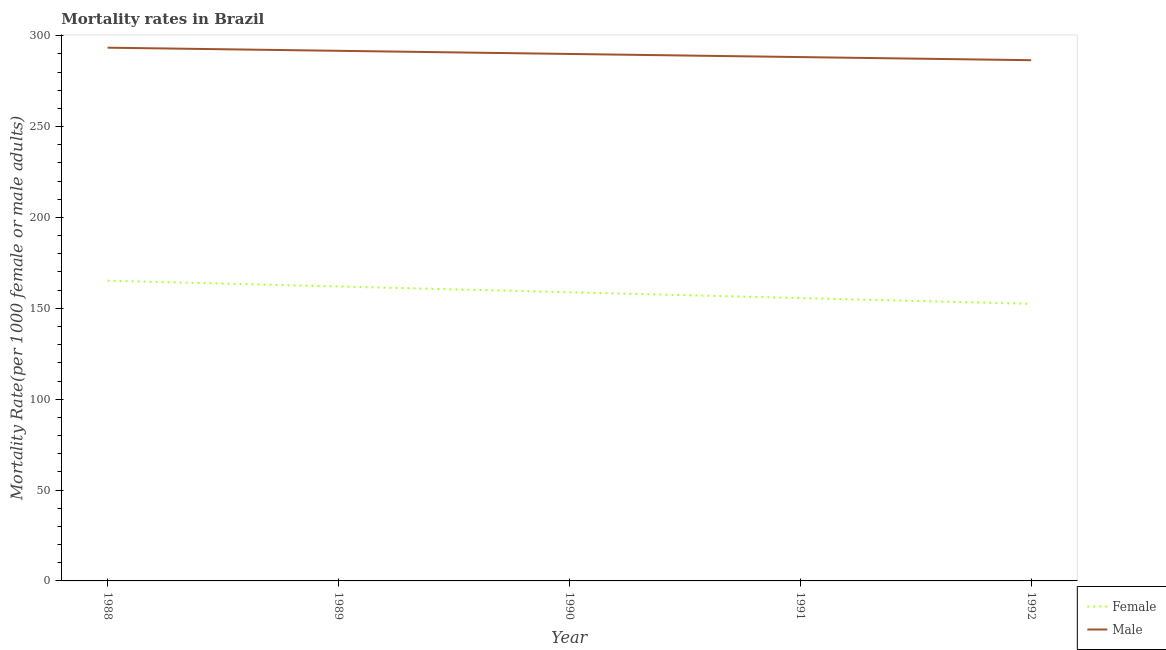Does the line corresponding to male mortality rate intersect with the line corresponding to female mortality rate?
Your answer should be compact. No. What is the female mortality rate in 1990?
Your answer should be very brief. 158.83. Across all years, what is the maximum female mortality rate?
Make the answer very short. 165.19. Across all years, what is the minimum male mortality rate?
Your answer should be compact. 286.51. In which year was the male mortality rate minimum?
Keep it short and to the point. 1992. What is the total male mortality rate in the graph?
Your answer should be compact. 1449.78. What is the difference between the female mortality rate in 1988 and that in 1989?
Offer a very short reply. 3.18. What is the difference between the female mortality rate in 1991 and the male mortality rate in 1988?
Offer a terse response. -137.76. What is the average male mortality rate per year?
Keep it short and to the point. 289.96. In the year 1991, what is the difference between the female mortality rate and male mortality rate?
Offer a terse response. -132.59. In how many years, is the female mortality rate greater than 130?
Keep it short and to the point. 5. What is the ratio of the male mortality rate in 1990 to that in 1992?
Keep it short and to the point. 1.01. What is the difference between the highest and the second highest female mortality rate?
Offer a terse response. 3.18. What is the difference between the highest and the lowest male mortality rate?
Provide a short and direct response. 6.89. Is the sum of the male mortality rate in 1988 and 1990 greater than the maximum female mortality rate across all years?
Your answer should be compact. Yes. Does the female mortality rate monotonically increase over the years?
Give a very brief answer. No. Is the male mortality rate strictly greater than the female mortality rate over the years?
Your response must be concise. Yes. How many lines are there?
Your answer should be very brief. 2. Are the values on the major ticks of Y-axis written in scientific E-notation?
Ensure brevity in your answer.  No. Where does the legend appear in the graph?
Keep it short and to the point. Bottom right. How are the legend labels stacked?
Ensure brevity in your answer.  Vertical. What is the title of the graph?
Provide a short and direct response. Mortality rates in Brazil. What is the label or title of the X-axis?
Your response must be concise. Year. What is the label or title of the Y-axis?
Your answer should be compact. Mortality Rate(per 1000 female or male adults). What is the Mortality Rate(per 1000 female or male adults) in Female in 1988?
Provide a succinct answer. 165.19. What is the Mortality Rate(per 1000 female or male adults) in Male in 1988?
Your answer should be compact. 293.4. What is the Mortality Rate(per 1000 female or male adults) in Female in 1989?
Your answer should be compact. 162.01. What is the Mortality Rate(per 1000 female or male adults) of Male in 1989?
Provide a succinct answer. 291.68. What is the Mortality Rate(per 1000 female or male adults) of Female in 1990?
Offer a very short reply. 158.83. What is the Mortality Rate(per 1000 female or male adults) of Male in 1990?
Keep it short and to the point. 289.96. What is the Mortality Rate(per 1000 female or male adults) in Female in 1991?
Offer a terse response. 155.65. What is the Mortality Rate(per 1000 female or male adults) of Male in 1991?
Make the answer very short. 288.23. What is the Mortality Rate(per 1000 female or male adults) in Female in 1992?
Provide a succinct answer. 152.47. What is the Mortality Rate(per 1000 female or male adults) of Male in 1992?
Make the answer very short. 286.51. Across all years, what is the maximum Mortality Rate(per 1000 female or male adults) in Female?
Make the answer very short. 165.19. Across all years, what is the maximum Mortality Rate(per 1000 female or male adults) of Male?
Your answer should be very brief. 293.4. Across all years, what is the minimum Mortality Rate(per 1000 female or male adults) of Female?
Provide a short and direct response. 152.47. Across all years, what is the minimum Mortality Rate(per 1000 female or male adults) of Male?
Give a very brief answer. 286.51. What is the total Mortality Rate(per 1000 female or male adults) of Female in the graph?
Provide a succinct answer. 794.15. What is the total Mortality Rate(per 1000 female or male adults) of Male in the graph?
Keep it short and to the point. 1449.78. What is the difference between the Mortality Rate(per 1000 female or male adults) in Female in 1988 and that in 1989?
Provide a short and direct response. 3.18. What is the difference between the Mortality Rate(per 1000 female or male adults) of Male in 1988 and that in 1989?
Provide a succinct answer. 1.72. What is the difference between the Mortality Rate(per 1000 female or male adults) of Female in 1988 and that in 1990?
Your answer should be compact. 6.36. What is the difference between the Mortality Rate(per 1000 female or male adults) of Male in 1988 and that in 1990?
Keep it short and to the point. 3.45. What is the difference between the Mortality Rate(per 1000 female or male adults) in Female in 1988 and that in 1991?
Keep it short and to the point. 9.54. What is the difference between the Mortality Rate(per 1000 female or male adults) in Male in 1988 and that in 1991?
Provide a succinct answer. 5.17. What is the difference between the Mortality Rate(per 1000 female or male adults) of Female in 1988 and that in 1992?
Your answer should be compact. 12.73. What is the difference between the Mortality Rate(per 1000 female or male adults) in Male in 1988 and that in 1992?
Provide a succinct answer. 6.89. What is the difference between the Mortality Rate(per 1000 female or male adults) in Female in 1989 and that in 1990?
Give a very brief answer. 3.18. What is the difference between the Mortality Rate(per 1000 female or male adults) in Male in 1989 and that in 1990?
Offer a very short reply. 1.72. What is the difference between the Mortality Rate(per 1000 female or male adults) in Female in 1989 and that in 1991?
Provide a short and direct response. 6.36. What is the difference between the Mortality Rate(per 1000 female or male adults) of Male in 1989 and that in 1991?
Your response must be concise. 3.45. What is the difference between the Mortality Rate(per 1000 female or male adults) of Female in 1989 and that in 1992?
Give a very brief answer. 9.55. What is the difference between the Mortality Rate(per 1000 female or male adults) in Male in 1989 and that in 1992?
Keep it short and to the point. 5.17. What is the difference between the Mortality Rate(per 1000 female or male adults) of Female in 1990 and that in 1991?
Your answer should be very brief. 3.18. What is the difference between the Mortality Rate(per 1000 female or male adults) in Male in 1990 and that in 1991?
Your answer should be compact. 1.72. What is the difference between the Mortality Rate(per 1000 female or male adults) of Female in 1990 and that in 1992?
Your answer should be compact. 6.36. What is the difference between the Mortality Rate(per 1000 female or male adults) of Male in 1990 and that in 1992?
Your answer should be very brief. 3.45. What is the difference between the Mortality Rate(per 1000 female or male adults) of Female in 1991 and that in 1992?
Your answer should be very brief. 3.18. What is the difference between the Mortality Rate(per 1000 female or male adults) in Male in 1991 and that in 1992?
Your response must be concise. 1.72. What is the difference between the Mortality Rate(per 1000 female or male adults) in Female in 1988 and the Mortality Rate(per 1000 female or male adults) in Male in 1989?
Provide a short and direct response. -126.49. What is the difference between the Mortality Rate(per 1000 female or male adults) of Female in 1988 and the Mortality Rate(per 1000 female or male adults) of Male in 1990?
Offer a very short reply. -124.76. What is the difference between the Mortality Rate(per 1000 female or male adults) in Female in 1988 and the Mortality Rate(per 1000 female or male adults) in Male in 1991?
Your answer should be very brief. -123.04. What is the difference between the Mortality Rate(per 1000 female or male adults) of Female in 1988 and the Mortality Rate(per 1000 female or male adults) of Male in 1992?
Your answer should be very brief. -121.32. What is the difference between the Mortality Rate(per 1000 female or male adults) in Female in 1989 and the Mortality Rate(per 1000 female or male adults) in Male in 1990?
Your answer should be compact. -127.94. What is the difference between the Mortality Rate(per 1000 female or male adults) in Female in 1989 and the Mortality Rate(per 1000 female or male adults) in Male in 1991?
Offer a very short reply. -126.22. What is the difference between the Mortality Rate(per 1000 female or male adults) in Female in 1989 and the Mortality Rate(per 1000 female or male adults) in Male in 1992?
Ensure brevity in your answer.  -124.5. What is the difference between the Mortality Rate(per 1000 female or male adults) of Female in 1990 and the Mortality Rate(per 1000 female or male adults) of Male in 1991?
Your answer should be very brief. -129.4. What is the difference between the Mortality Rate(per 1000 female or male adults) of Female in 1990 and the Mortality Rate(per 1000 female or male adults) of Male in 1992?
Provide a succinct answer. -127.68. What is the difference between the Mortality Rate(per 1000 female or male adults) in Female in 1991 and the Mortality Rate(per 1000 female or male adults) in Male in 1992?
Your answer should be compact. -130.86. What is the average Mortality Rate(per 1000 female or male adults) in Female per year?
Your answer should be very brief. 158.83. What is the average Mortality Rate(per 1000 female or male adults) of Male per year?
Your answer should be very brief. 289.96. In the year 1988, what is the difference between the Mortality Rate(per 1000 female or male adults) of Female and Mortality Rate(per 1000 female or male adults) of Male?
Your answer should be very brief. -128.21. In the year 1989, what is the difference between the Mortality Rate(per 1000 female or male adults) of Female and Mortality Rate(per 1000 female or male adults) of Male?
Make the answer very short. -129.67. In the year 1990, what is the difference between the Mortality Rate(per 1000 female or male adults) of Female and Mortality Rate(per 1000 female or male adults) of Male?
Keep it short and to the point. -131.13. In the year 1991, what is the difference between the Mortality Rate(per 1000 female or male adults) in Female and Mortality Rate(per 1000 female or male adults) in Male?
Offer a terse response. -132.59. In the year 1992, what is the difference between the Mortality Rate(per 1000 female or male adults) of Female and Mortality Rate(per 1000 female or male adults) of Male?
Ensure brevity in your answer.  -134.04. What is the ratio of the Mortality Rate(per 1000 female or male adults) of Female in 1988 to that in 1989?
Your answer should be compact. 1.02. What is the ratio of the Mortality Rate(per 1000 female or male adults) of Male in 1988 to that in 1989?
Give a very brief answer. 1.01. What is the ratio of the Mortality Rate(per 1000 female or male adults) of Female in 1988 to that in 1990?
Make the answer very short. 1.04. What is the ratio of the Mortality Rate(per 1000 female or male adults) of Male in 1988 to that in 1990?
Keep it short and to the point. 1.01. What is the ratio of the Mortality Rate(per 1000 female or male adults) of Female in 1988 to that in 1991?
Your answer should be very brief. 1.06. What is the ratio of the Mortality Rate(per 1000 female or male adults) in Male in 1988 to that in 1991?
Your answer should be compact. 1.02. What is the ratio of the Mortality Rate(per 1000 female or male adults) in Female in 1988 to that in 1992?
Make the answer very short. 1.08. What is the ratio of the Mortality Rate(per 1000 female or male adults) in Male in 1988 to that in 1992?
Provide a succinct answer. 1.02. What is the ratio of the Mortality Rate(per 1000 female or male adults) in Female in 1989 to that in 1990?
Your answer should be very brief. 1.02. What is the ratio of the Mortality Rate(per 1000 female or male adults) in Male in 1989 to that in 1990?
Provide a short and direct response. 1.01. What is the ratio of the Mortality Rate(per 1000 female or male adults) of Female in 1989 to that in 1991?
Provide a succinct answer. 1.04. What is the ratio of the Mortality Rate(per 1000 female or male adults) in Female in 1989 to that in 1992?
Your answer should be very brief. 1.06. What is the ratio of the Mortality Rate(per 1000 female or male adults) of Male in 1989 to that in 1992?
Your answer should be very brief. 1.02. What is the ratio of the Mortality Rate(per 1000 female or male adults) in Female in 1990 to that in 1991?
Make the answer very short. 1.02. What is the ratio of the Mortality Rate(per 1000 female or male adults) in Male in 1990 to that in 1991?
Offer a terse response. 1.01. What is the ratio of the Mortality Rate(per 1000 female or male adults) in Female in 1990 to that in 1992?
Give a very brief answer. 1.04. What is the ratio of the Mortality Rate(per 1000 female or male adults) of Female in 1991 to that in 1992?
Offer a terse response. 1.02. What is the ratio of the Mortality Rate(per 1000 female or male adults) of Male in 1991 to that in 1992?
Keep it short and to the point. 1.01. What is the difference between the highest and the second highest Mortality Rate(per 1000 female or male adults) in Female?
Offer a terse response. 3.18. What is the difference between the highest and the second highest Mortality Rate(per 1000 female or male adults) of Male?
Ensure brevity in your answer.  1.72. What is the difference between the highest and the lowest Mortality Rate(per 1000 female or male adults) of Female?
Your answer should be compact. 12.73. What is the difference between the highest and the lowest Mortality Rate(per 1000 female or male adults) in Male?
Offer a terse response. 6.89. 